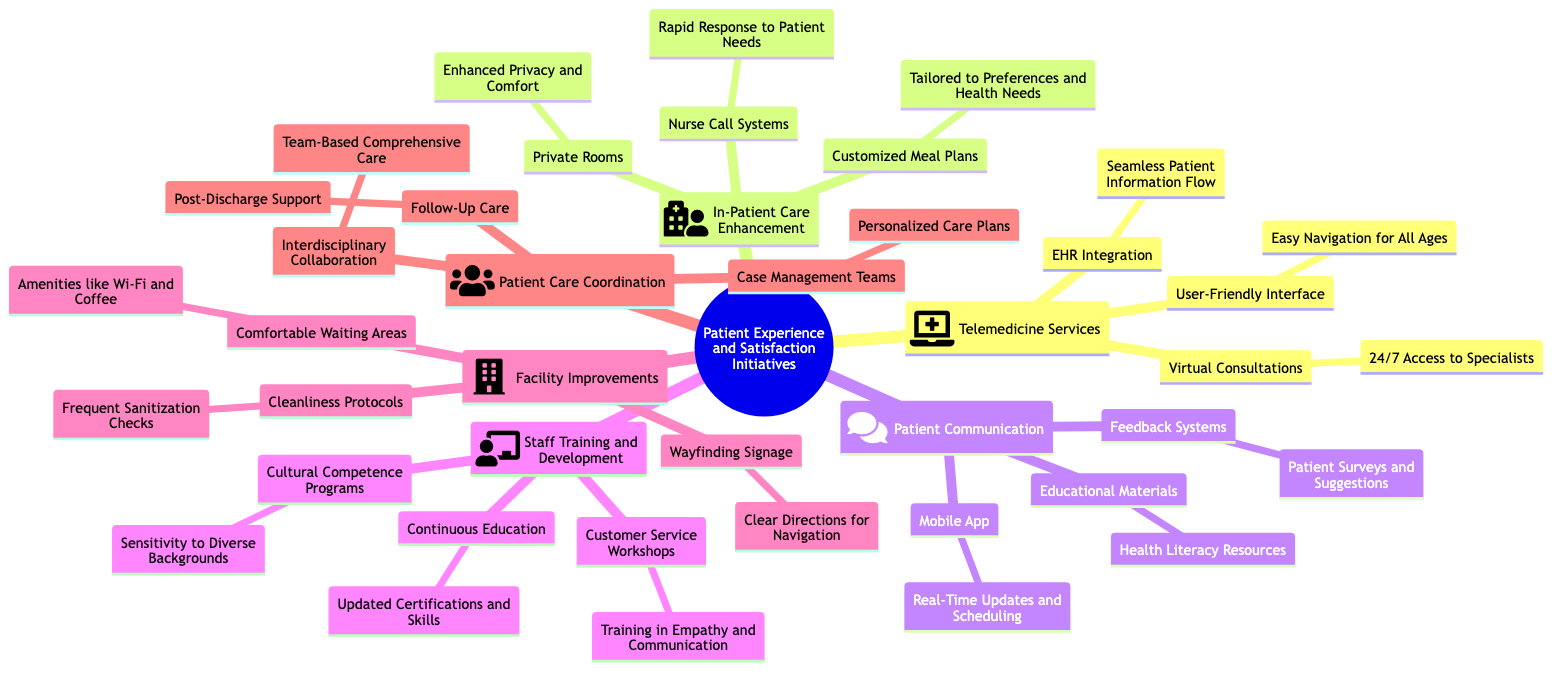What are the three main categories of Patient Experience and Satisfaction Initiatives? The diagram lists six main categories: Telemedicine Services, In-Patient Care Enhancement, Patient Communication, Staff Training and Development, Facility Improvements, and Patient Care Coordination. Therefore, I would select any three categories from this list.
Answer: Telemedicine Services, In-Patient Care Enhancement, Patient Communication What type of accessibility is provided by Virtual Consultations? The diagram states that Virtual Consultations offer 24/7 Access to Specialists, highlighting the convenience and availability of these services for patients.
Answer: 24/7 Access to Specialists How many forms of Patient Communication are included in the diagram? There are three forms listed under Patient Communication: Mobile App, Feedback Systems, and Educational Materials. By counting these items, we derive the total.
Answer: 3 Which service is proposed for timely responses to patient needs? The Nurse Call Systems are described in the diagram as providing Rapid Response to Patient Needs, which conveys their purpose clearly.
Answer: Rapid Response to Patient Needs What amenities are mentioned to enhance Comfortable Waiting Areas? The diagram includes Free Wi-Fi and Coffee as amenities that contribute to the comfort of waiting areas, indicating how patient experience is considered in those spaces.
Answer: Free Wi-Fi and Coffee What training programs are included under Staff Training and Development? The diagram lists three specific programs: Customer Service Workshops, Cultural Competence Programs, and Continuous Education. These programs are aimed at enhancing staff capabilities for better patient interactions.
Answer: Customer Service Workshops, Cultural Competence Programs, Continuous Education What is the purpose of Case Management Teams in Patient Care Coordination? According to the diagram, Case Management Teams provide Personalized Care Plans, which indicates a tailored approach to managing patient care for better outcomes.
Answer: Personalized Care Plans What key improvement does Cleanliness Protocols address in Facility Improvements? The diagram explicitly mentions Frequent Sanitization and Hygiene Checks as part of the Cleanliness Protocols, indicating how these practices aim to improve the facility's environment for patients.
Answer: Frequent Sanitization and Hygiene Checks 